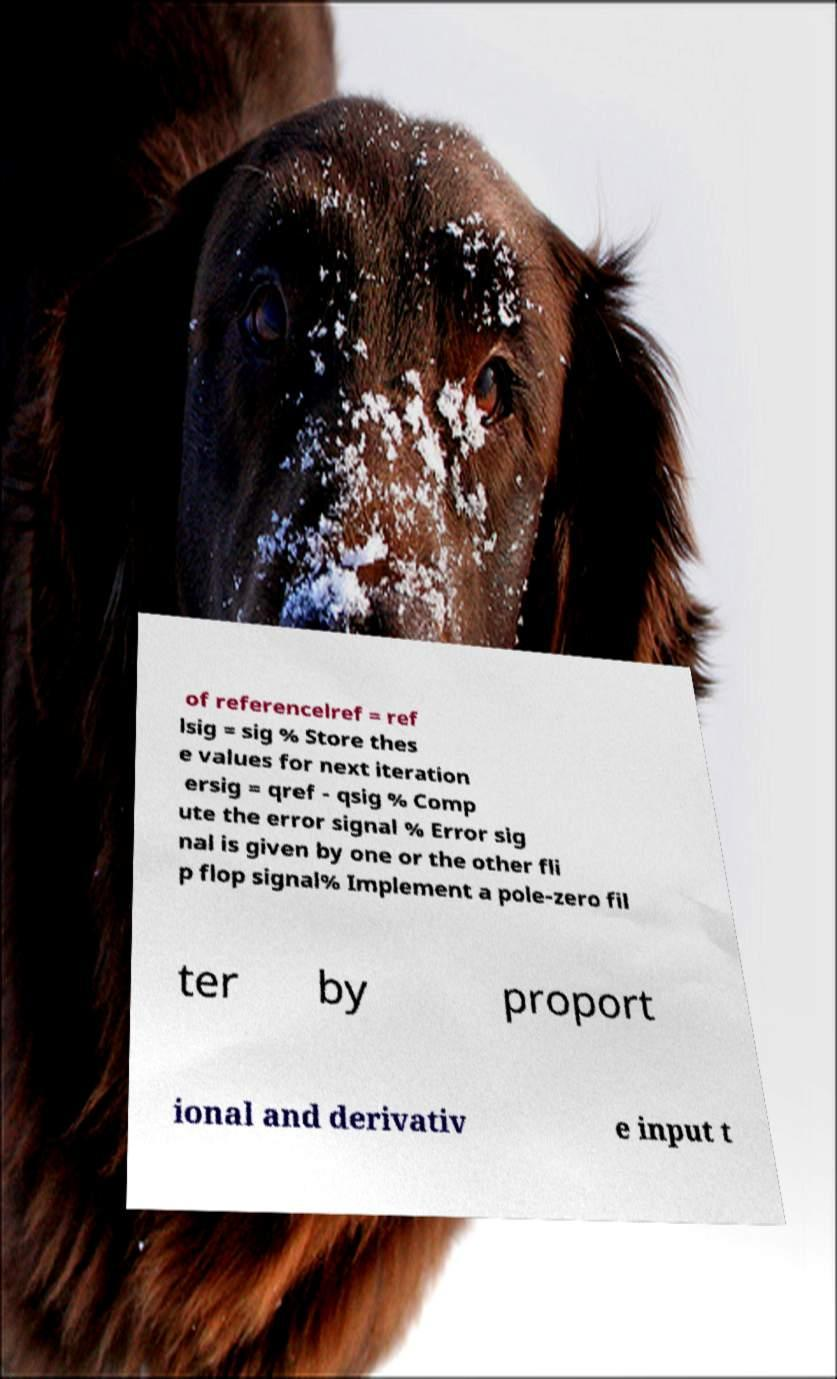Could you extract and type out the text from this image? of referencelref = ref lsig = sig % Store thes e values for next iteration ersig = qref - qsig % Comp ute the error signal % Error sig nal is given by one or the other fli p flop signal% Implement a pole-zero fil ter by proport ional and derivativ e input t 